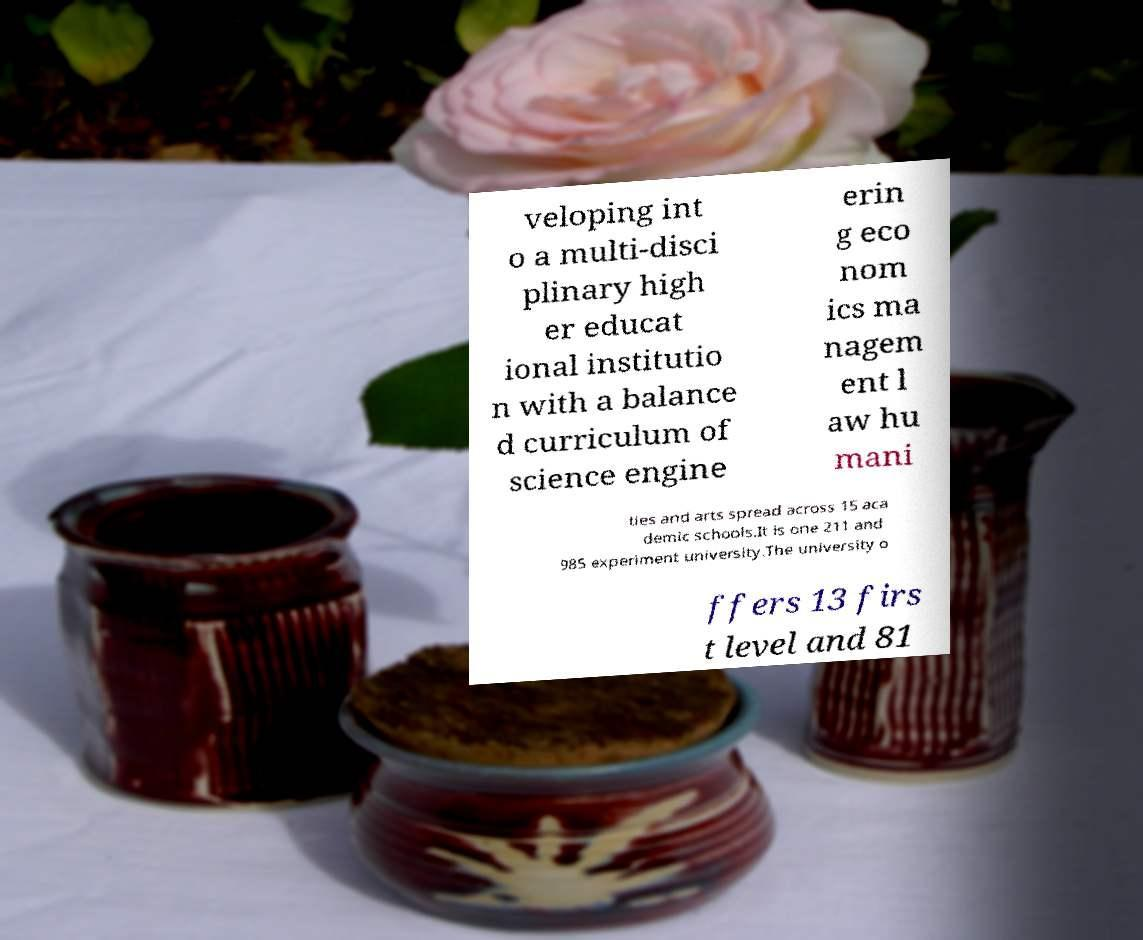Could you assist in decoding the text presented in this image and type it out clearly? veloping int o a multi-disci plinary high er educat ional institutio n with a balance d curriculum of science engine erin g eco nom ics ma nagem ent l aw hu mani ties and arts spread across 15 aca demic schools.It is one 211 and 985 experiment university.The university o ffers 13 firs t level and 81 